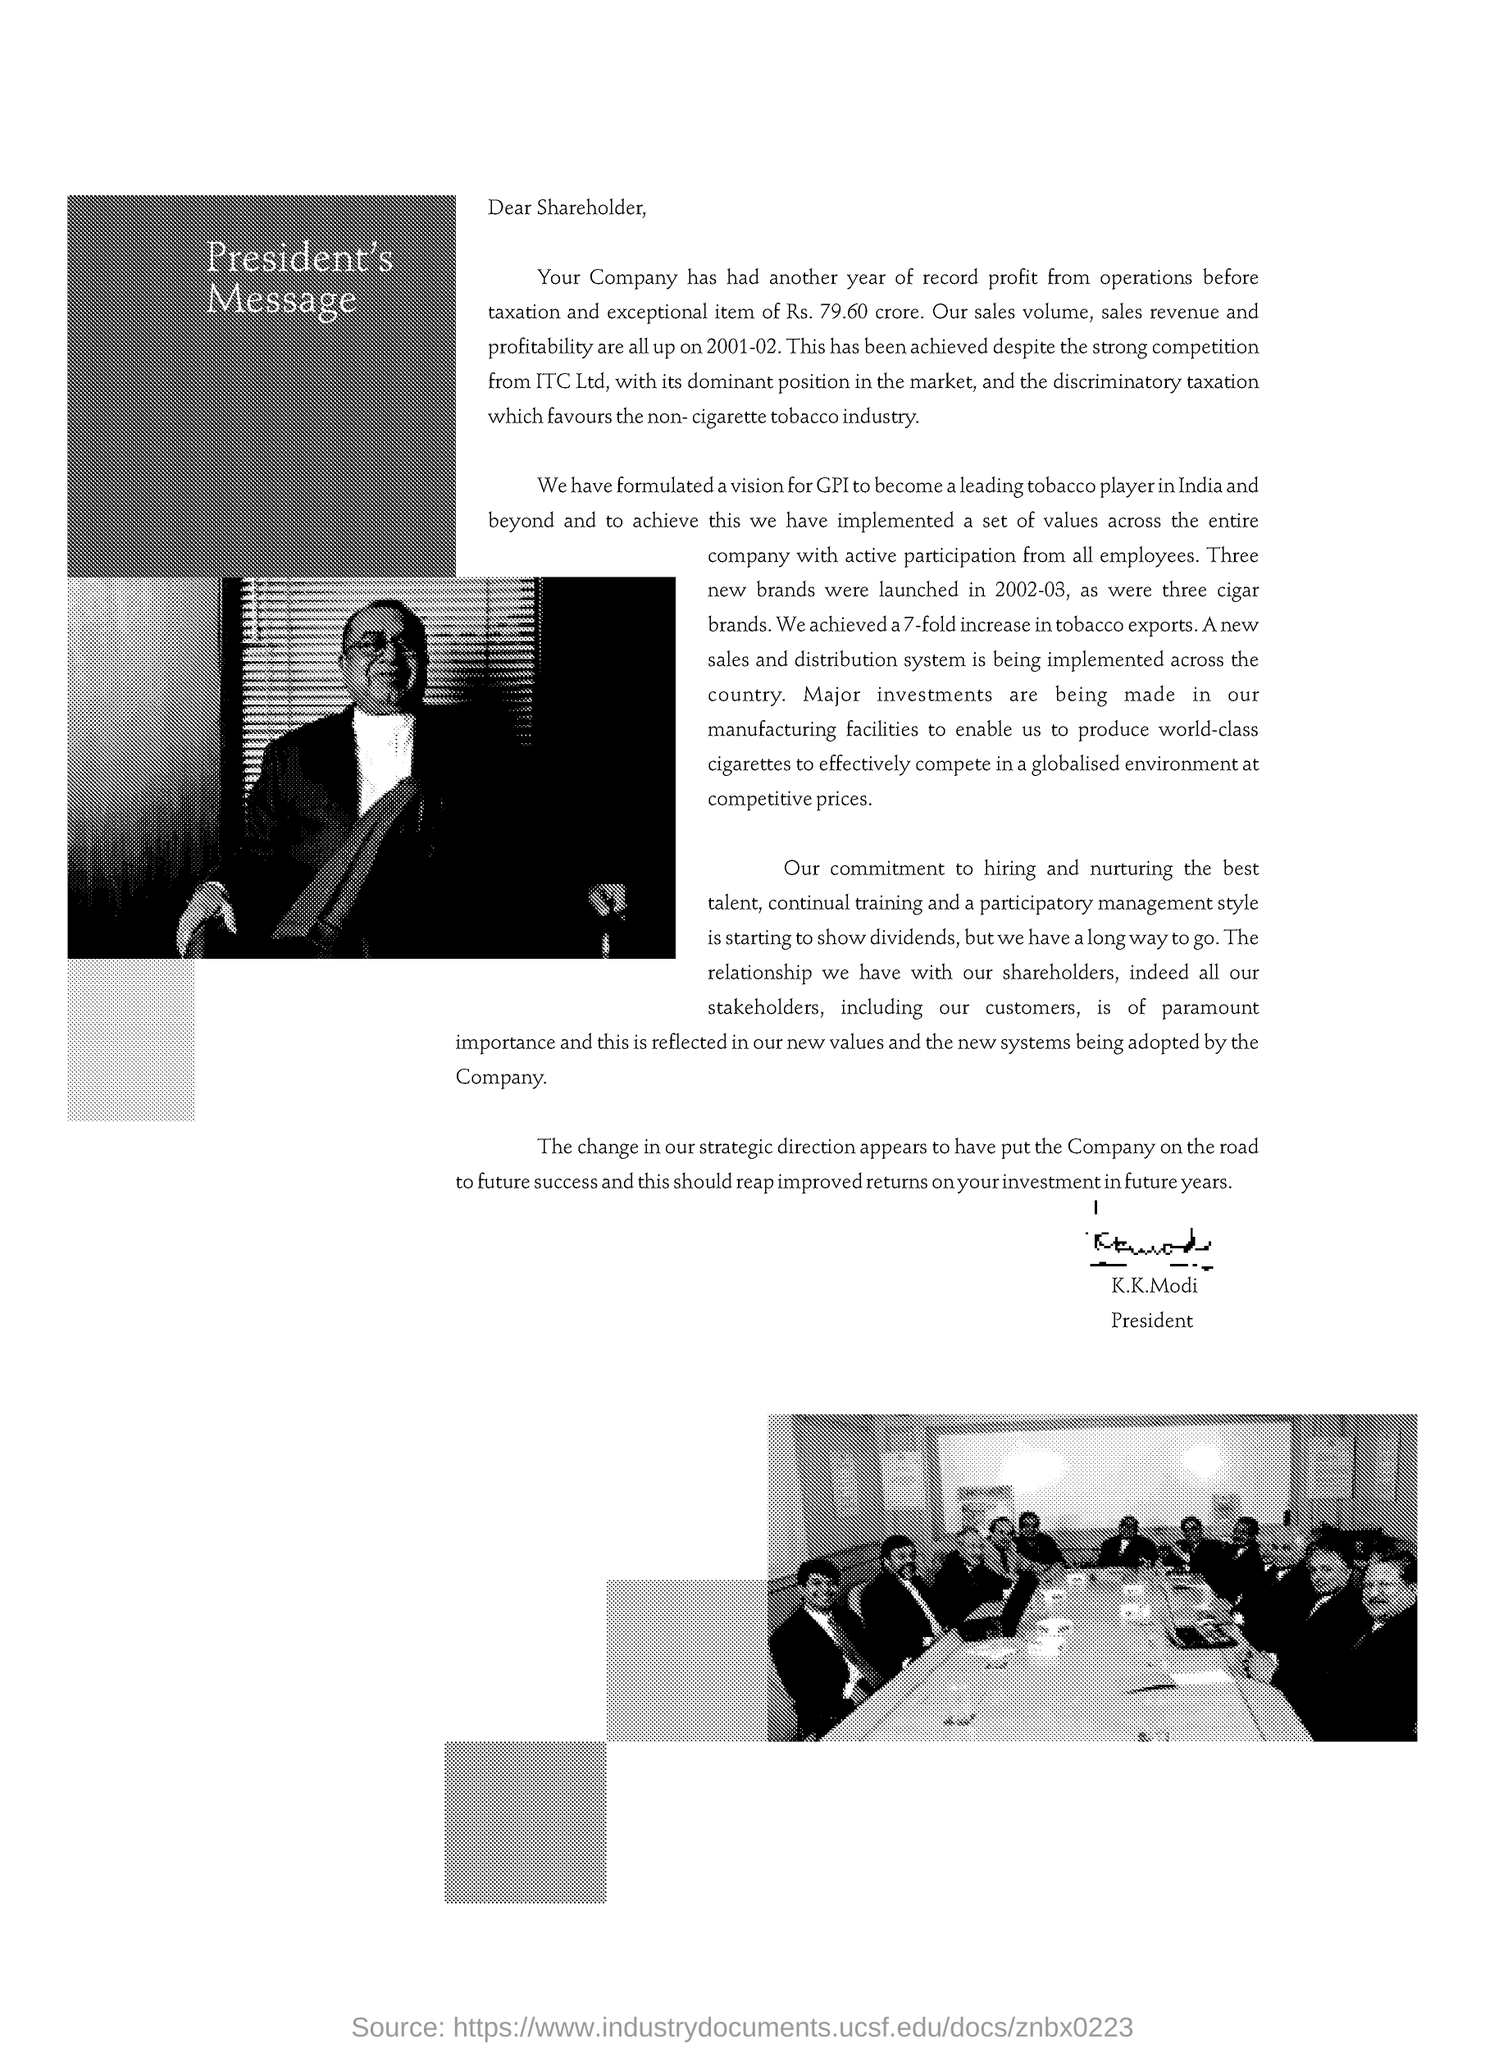Give some essential details in this illustration. Despite strong competition from ITC, the profit has been achieved. 